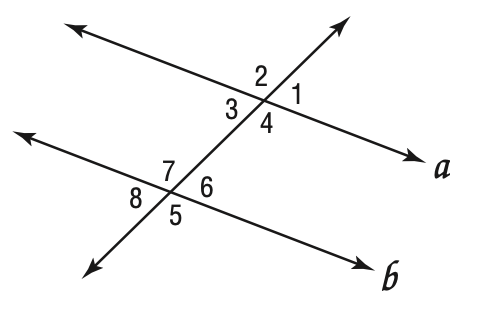Question: If a \parallel b in the diagram below, which of the following may not be true?
Choices:
A. \angle 1 \cong \angle 3
B. \angle 2 \cong \angle 5
C. \angle 4 \cong \angle 7
D. \angle 8 \cong \angle 2
Answer with the letter. Answer: D 